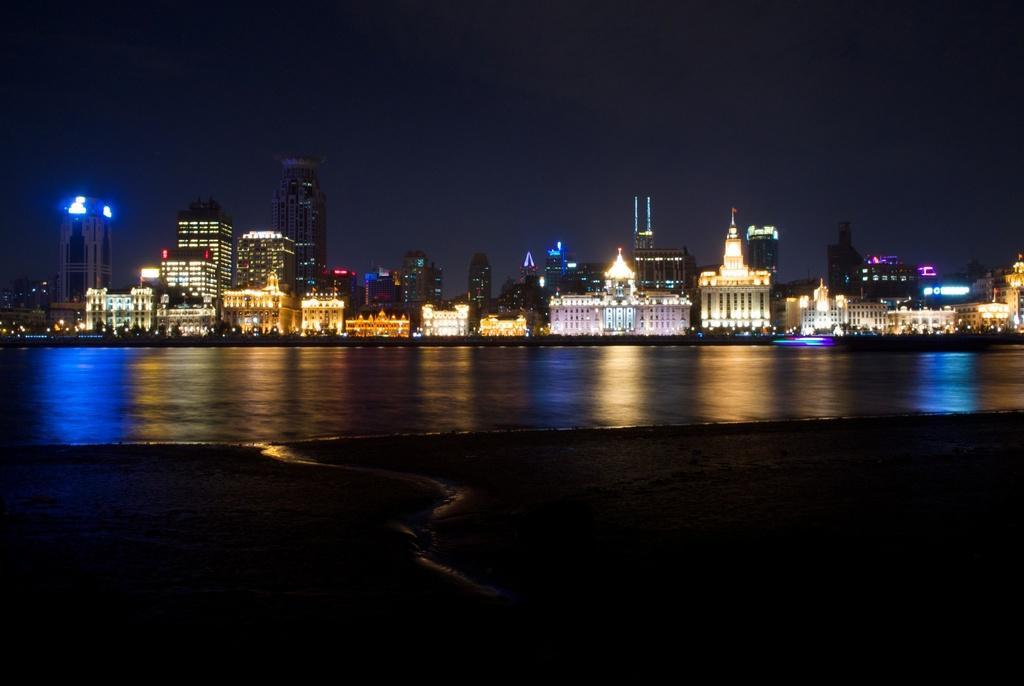Could you give a brief overview of what you see in this image? In this picture we can see water and ground. In the background of the image we can see buildings, lights and sky. 